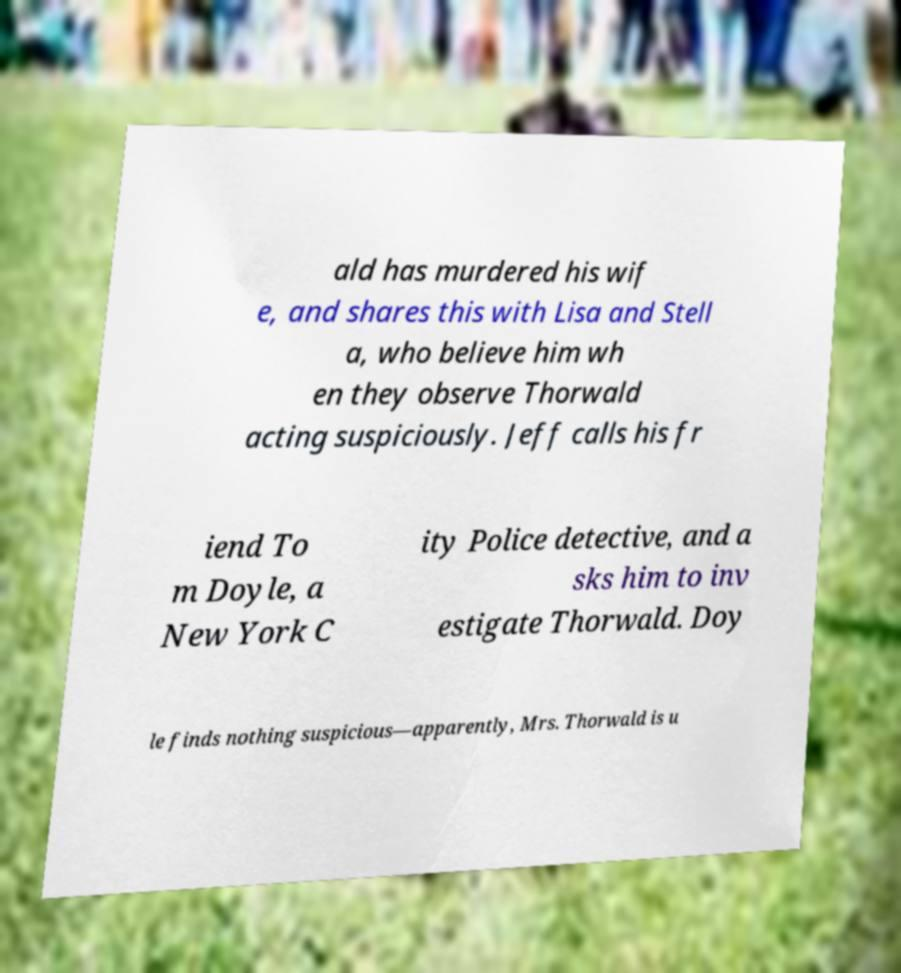Can you read and provide the text displayed in the image?This photo seems to have some interesting text. Can you extract and type it out for me? ald has murdered his wif e, and shares this with Lisa and Stell a, who believe him wh en they observe Thorwald acting suspiciously. Jeff calls his fr iend To m Doyle, a New York C ity Police detective, and a sks him to inv estigate Thorwald. Doy le finds nothing suspicious—apparently, Mrs. Thorwald is u 